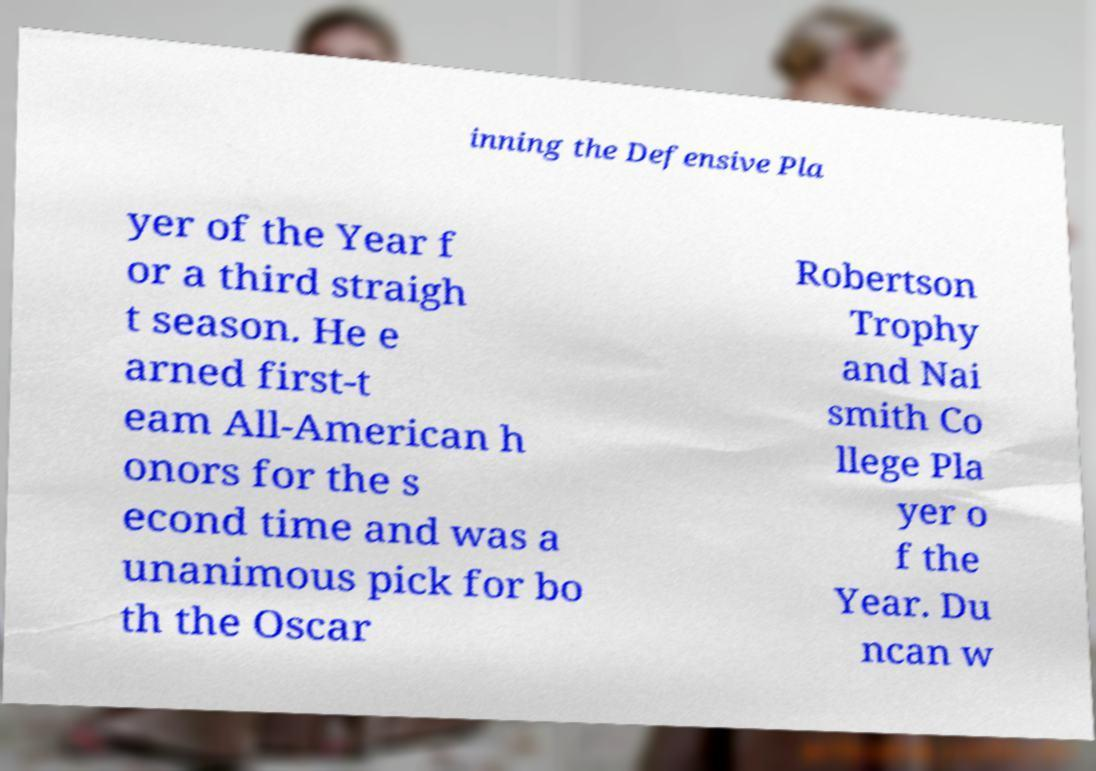Please read and relay the text visible in this image. What does it say? inning the Defensive Pla yer of the Year f or a third straigh t season. He e arned first-t eam All-American h onors for the s econd time and was a unanimous pick for bo th the Oscar Robertson Trophy and Nai smith Co llege Pla yer o f the Year. Du ncan w 